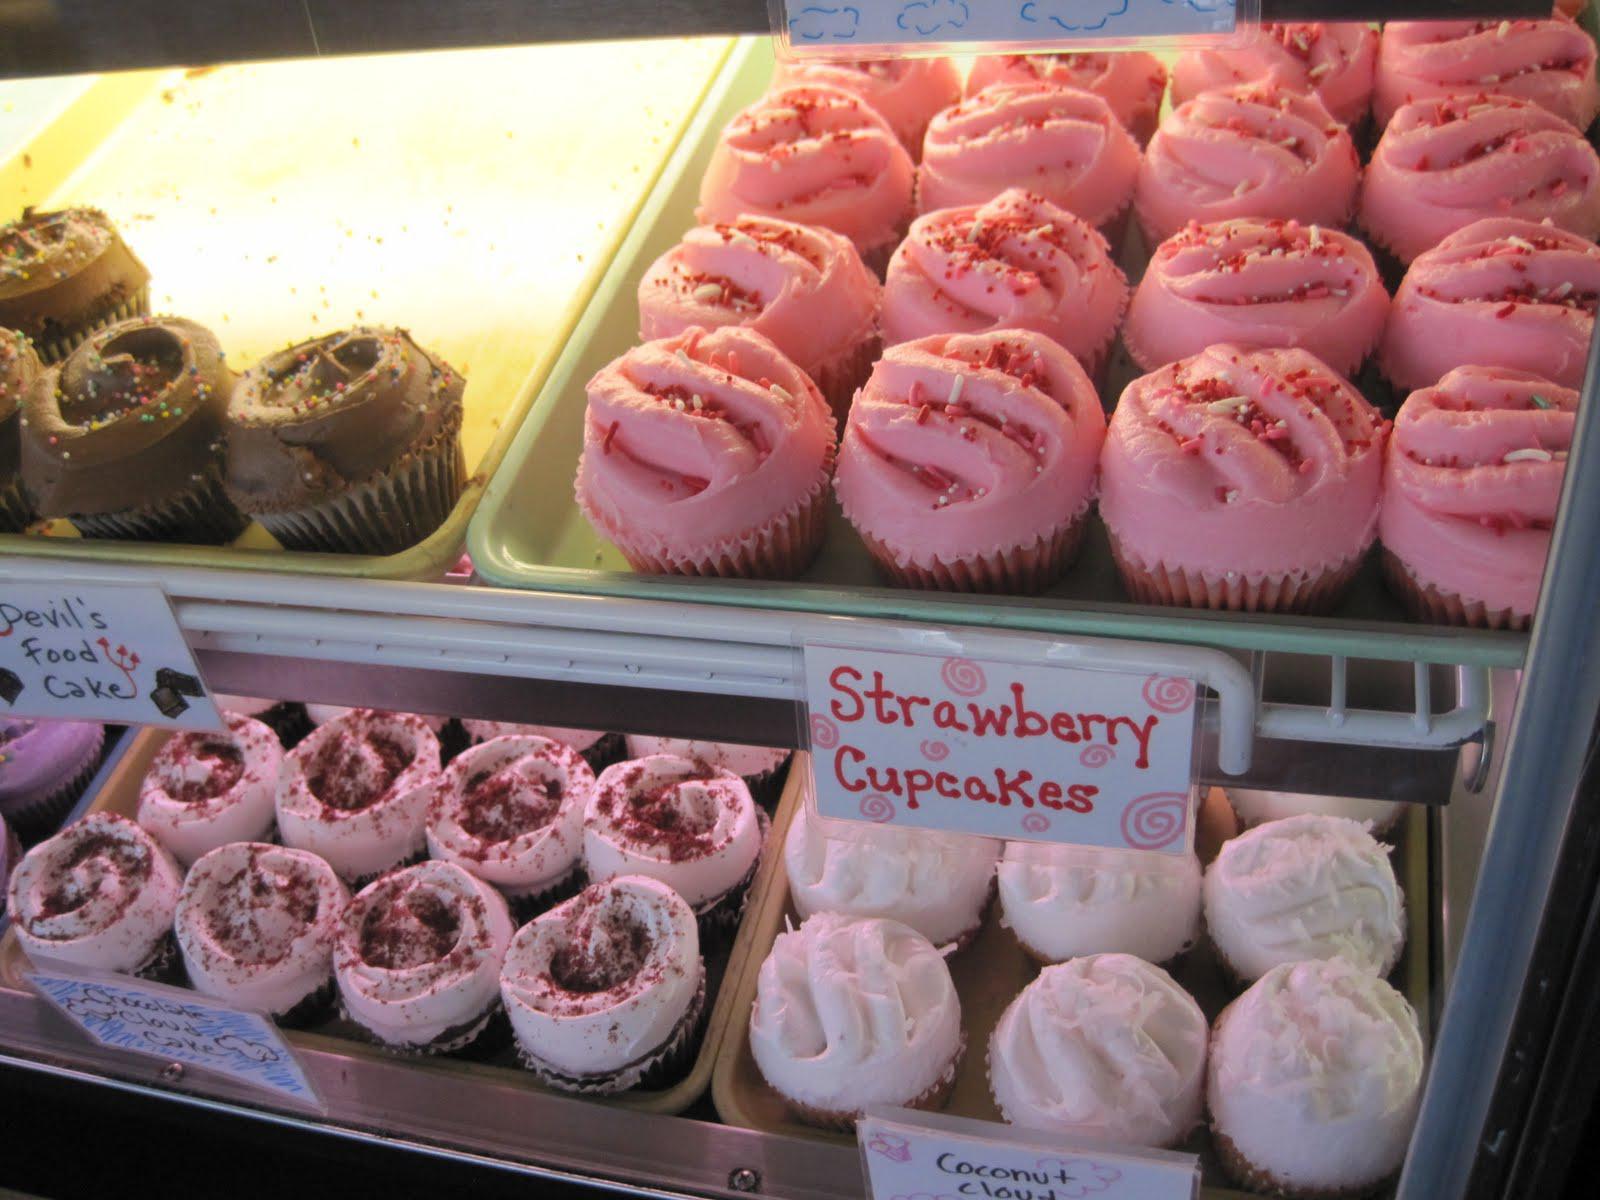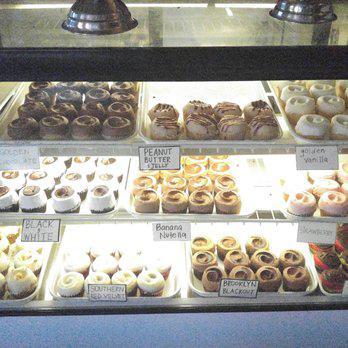The first image is the image on the left, the second image is the image on the right. Evaluate the accuracy of this statement regarding the images: "One image shows a line of desserts displayed under glass on silver pedestals atop a counter, and the other image shows a glass display front that includes pink, yellow, white and brown frosted cupcakes.". Is it true? Answer yes or no. No. The first image is the image on the left, the second image is the image on the right. For the images shown, is this caption "There are lemon pastries on the middle shelf." true? Answer yes or no. No. 